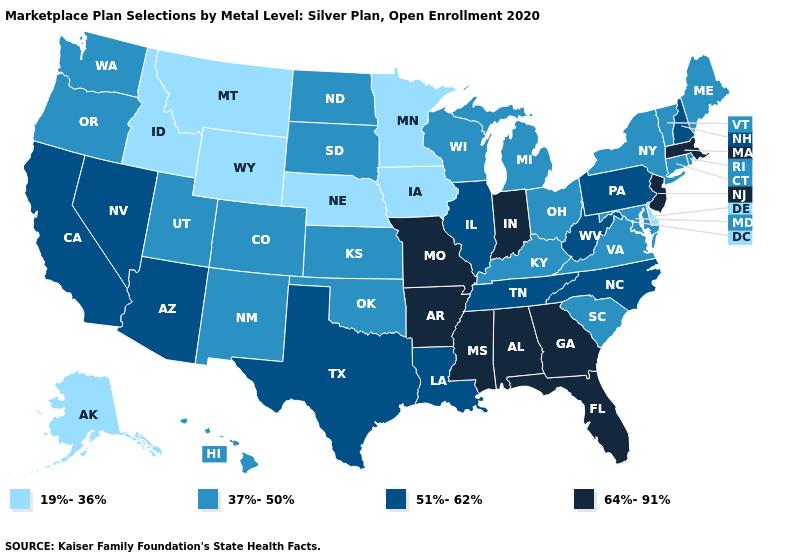Among the states that border Illinois , which have the highest value?
Quick response, please. Indiana, Missouri. Name the states that have a value in the range 64%-91%?
Quick response, please. Alabama, Arkansas, Florida, Georgia, Indiana, Massachusetts, Mississippi, Missouri, New Jersey. Name the states that have a value in the range 37%-50%?
Quick response, please. Colorado, Connecticut, Hawaii, Kansas, Kentucky, Maine, Maryland, Michigan, New Mexico, New York, North Dakota, Ohio, Oklahoma, Oregon, Rhode Island, South Carolina, South Dakota, Utah, Vermont, Virginia, Washington, Wisconsin. What is the lowest value in states that border Oregon?
Short answer required. 19%-36%. What is the highest value in the USA?
Be succinct. 64%-91%. Does Missouri have the highest value in the MidWest?
Answer briefly. Yes. What is the value of North Carolina?
Concise answer only. 51%-62%. Does the first symbol in the legend represent the smallest category?
Concise answer only. Yes. Does Minnesota have the highest value in the MidWest?
Concise answer only. No. Does Pennsylvania have a higher value than Vermont?
Keep it brief. Yes. Does the first symbol in the legend represent the smallest category?
Concise answer only. Yes. Among the states that border New Jersey , does Pennsylvania have the highest value?
Concise answer only. Yes. Among the states that border Kansas , which have the highest value?
Quick response, please. Missouri. Is the legend a continuous bar?
Short answer required. No. What is the value of New Hampshire?
Answer briefly. 51%-62%. 